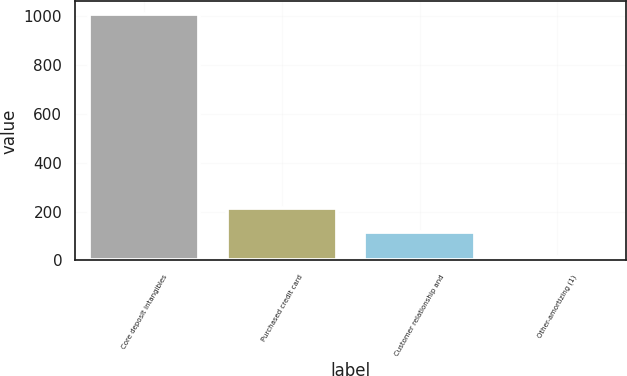<chart> <loc_0><loc_0><loc_500><loc_500><bar_chart><fcel>Core deposit intangibles<fcel>Purchased credit card<fcel>Customer relationship and<fcel>Other-amortizing (1)<nl><fcel>1011<fcel>215<fcel>115.5<fcel>16<nl></chart> 